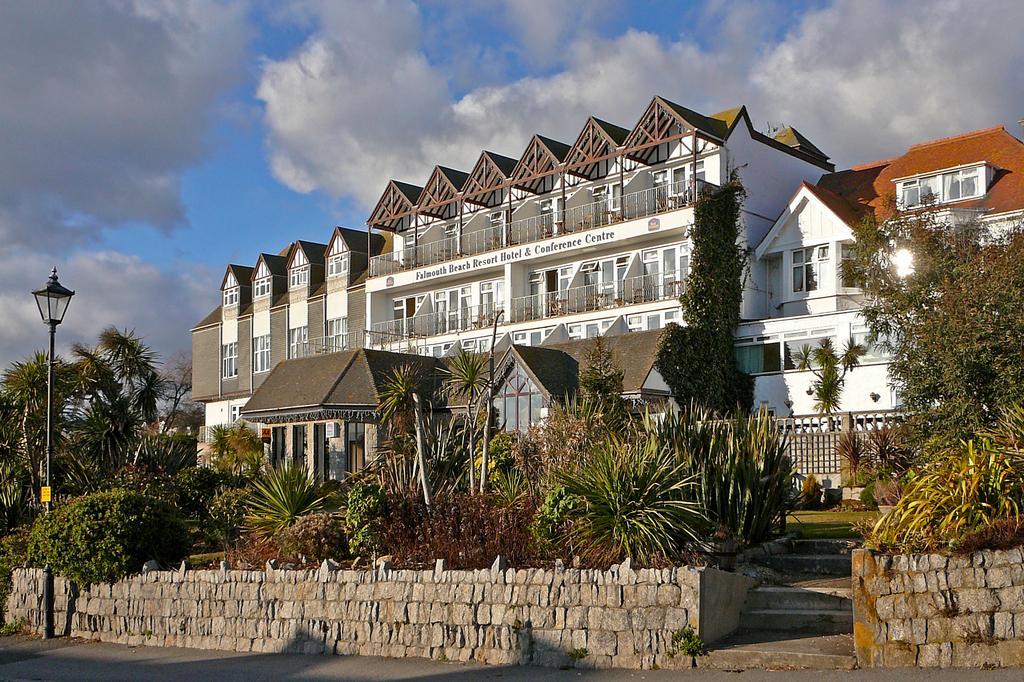In one or two sentences, can you explain what this image depicts? In this picture we can see a pole with light. On the right side of the pole there are plants, trees, wall and buildings. Behind the buildings there is a sky. 